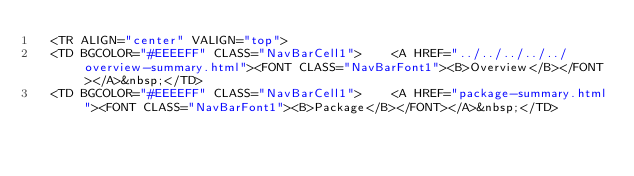Convert code to text. <code><loc_0><loc_0><loc_500><loc_500><_HTML_>  <TR ALIGN="center" VALIGN="top">
  <TD BGCOLOR="#EEEEFF" CLASS="NavBarCell1">    <A HREF="../../../../../overview-summary.html"><FONT CLASS="NavBarFont1"><B>Overview</B></FONT></A>&nbsp;</TD>
  <TD BGCOLOR="#EEEEFF" CLASS="NavBarCell1">    <A HREF="package-summary.html"><FONT CLASS="NavBarFont1"><B>Package</B></FONT></A>&nbsp;</TD></code> 